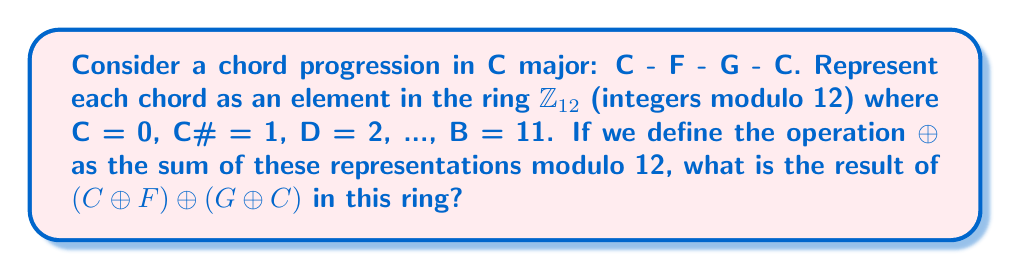Teach me how to tackle this problem. Let's approach this step-by-step:

1) First, we need to represent each chord as an element in $\mathbb{Z}_{12}$:
   C = 0
   F = 5
   G = 7

2) Now, we can rewrite our expression using these numbers:
   $(0 \oplus 5) \oplus (7 \oplus 0)$

3) Let's solve the parentheses first:
   $0 \oplus 5 = 5$ (in $\mathbb{Z}_{12}$)
   $7 \oplus 0 = 7$ (in $\mathbb{Z}_{12}$)

4) Our expression is now:
   $5 \oplus 7$

5) In $\mathbb{Z}_{12}$, this is equivalent to:
   $5 + 7 = 12 \equiv 0 \pmod{12}$

6) Therefore, the final result is 0, which corresponds back to the C chord.

This result demonstrates the cyclic nature of chord progressions in music theory, where we often return to the tonic (in this case, C) after a progression. In ring theory terms, we've shown that this particular combination of chords is equivalent to the identity element (0) in the ring $\mathbb{Z}_{12}$.
Answer: 0 (which represents the C chord) 